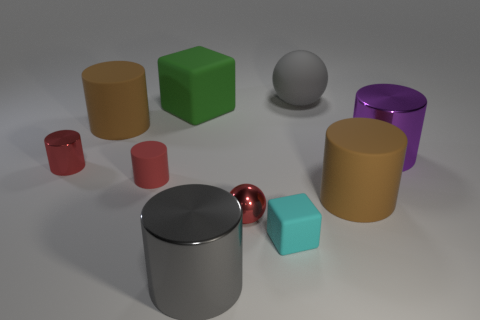What number of metallic objects are either purple things or gray spheres?
Provide a short and direct response. 1. What size is the other matte thing that is the same shape as the green matte thing?
Provide a short and direct response. Small. There is a gray sphere; is its size the same as the cyan block in front of the rubber ball?
Give a very brief answer. No. The green thing to the left of the big gray shiny object has what shape?
Your response must be concise. Cube. What color is the small metal cylinder that is behind the small cyan object left of the large purple shiny cylinder?
Make the answer very short. Red. The other big shiny thing that is the same shape as the large purple object is what color?
Provide a short and direct response. Gray. How many tiny metal things are the same color as the metal sphere?
Your answer should be compact. 1. Do the metallic ball and the small rubber object that is behind the small block have the same color?
Keep it short and to the point. Yes. There is a matte thing that is both behind the small red matte cylinder and to the left of the large green block; what shape is it?
Offer a terse response. Cylinder. What is the material of the sphere that is in front of the cylinder to the left of the brown cylinder behind the purple cylinder?
Provide a succinct answer. Metal. 